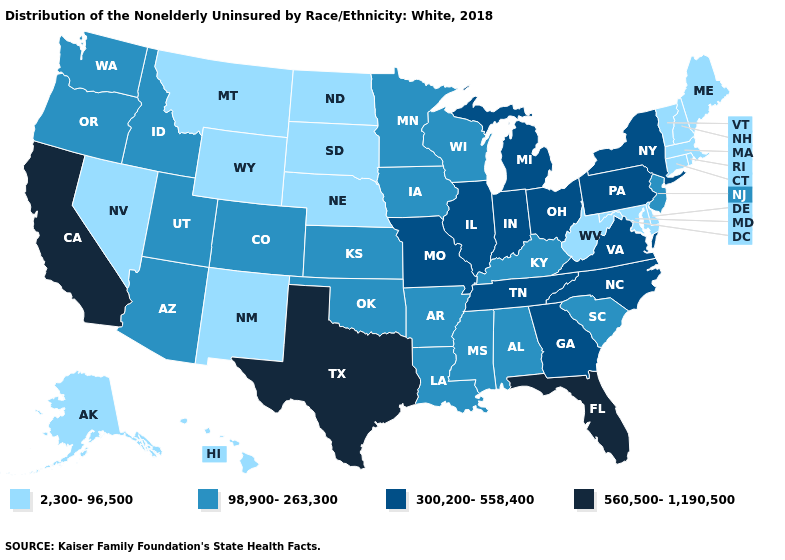What is the value of Minnesota?
Concise answer only. 98,900-263,300. Name the states that have a value in the range 560,500-1,190,500?
Give a very brief answer. California, Florida, Texas. What is the lowest value in the South?
Quick response, please. 2,300-96,500. What is the value of Wyoming?
Be succinct. 2,300-96,500. Among the states that border North Carolina , which have the highest value?
Keep it brief. Georgia, Tennessee, Virginia. Does Massachusetts have the lowest value in the Northeast?
Keep it brief. Yes. Name the states that have a value in the range 560,500-1,190,500?
Answer briefly. California, Florida, Texas. What is the highest value in the West ?
Be succinct. 560,500-1,190,500. What is the value of Utah?
Keep it brief. 98,900-263,300. What is the highest value in states that border Ohio?
Short answer required. 300,200-558,400. What is the value of California?
Quick response, please. 560,500-1,190,500. Does North Carolina have the lowest value in the USA?
Short answer required. No. What is the lowest value in states that border Maryland?
Keep it brief. 2,300-96,500. What is the highest value in the USA?
Keep it brief. 560,500-1,190,500. What is the value of Michigan?
Give a very brief answer. 300,200-558,400. 